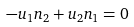Convert formula to latex. <formula><loc_0><loc_0><loc_500><loc_500>- u _ { 1 } n _ { 2 } + u _ { 2 } n _ { 1 } = 0</formula> 